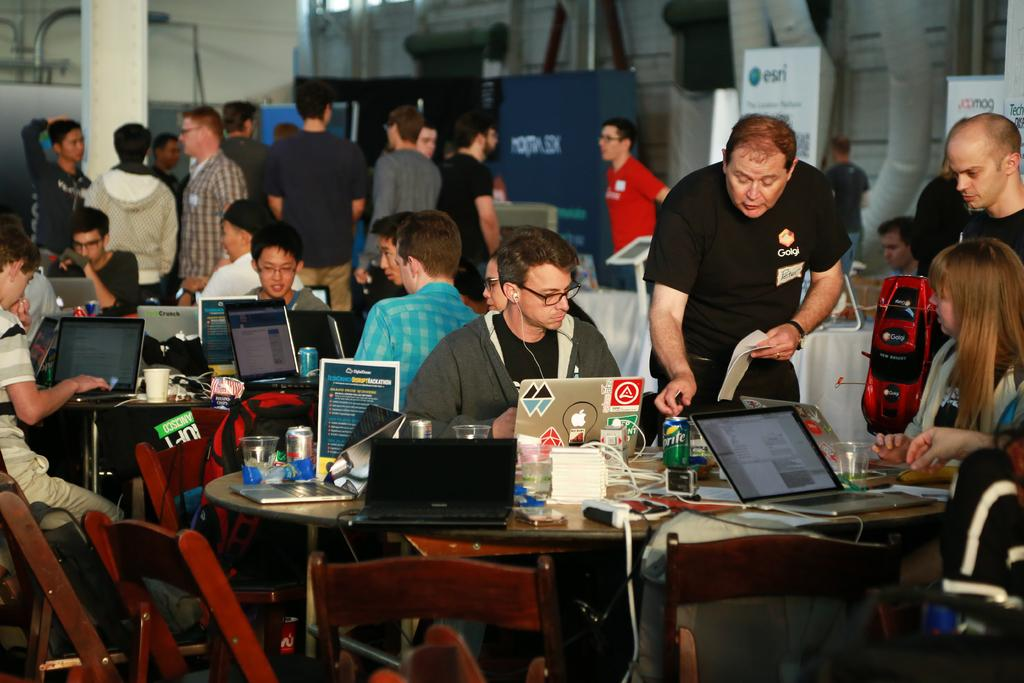What are the people in the image doing? sitting on chairs? What are the people standing in the image doing? The people standing in the image might be conversing with others or waiting for their turn to sit down. What is on the table in the image? There are laptops, a water bottle, a charger, and tissue papers on the table. What might be used for charging electronic devices in the image? The charger on the table can be used for charging electronic devices. What type of breakfast is being served on the table in the image? There is no breakfast visible in the image; only a water bottle, a charger, and tissue papers are present on the table. Can you see any seeds on the table in the image? There are no seeds visible on the table in the image. 